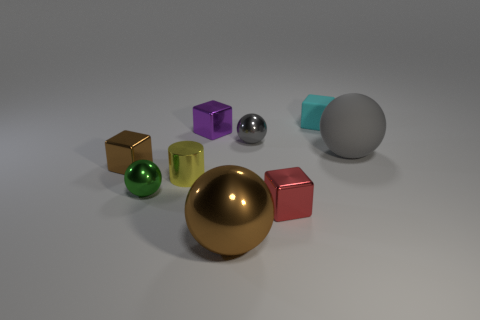Is there a small metallic cube of the same color as the large metallic sphere?
Make the answer very short. Yes. Is there a red metal cube on the right side of the sphere that is behind the large gray matte sphere?
Give a very brief answer. Yes. The cyan matte thing that is the same size as the purple thing is what shape?
Provide a short and direct response. Cube. How many things are small objects that are on the right side of the purple block or blue rubber balls?
Offer a terse response. 3. What number of other things are made of the same material as the yellow cylinder?
Your response must be concise. 6. What is the shape of the tiny thing that is the same color as the large metallic sphere?
Offer a very short reply. Cube. What is the size of the sphere left of the big metallic thing?
Keep it short and to the point. Small. What is the shape of the other big object that is made of the same material as the purple thing?
Provide a short and direct response. Sphere. Are the big gray thing and the large ball that is left of the tiny cyan object made of the same material?
Keep it short and to the point. No. There is a big object right of the brown shiny ball; does it have the same shape as the green object?
Your answer should be very brief. Yes. 